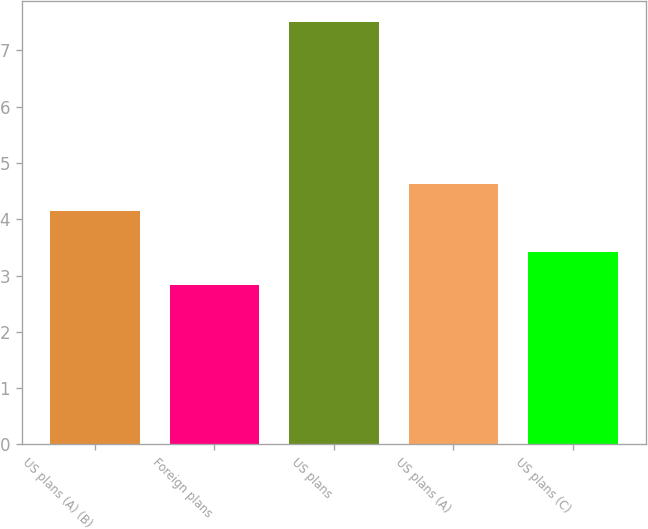Convert chart. <chart><loc_0><loc_0><loc_500><loc_500><bar_chart><fcel>US plans (A) (B)<fcel>Foreign plans<fcel>US plans<fcel>US plans (A)<fcel>US plans (C)<nl><fcel>4.15<fcel>2.84<fcel>7.5<fcel>4.62<fcel>3.42<nl></chart> 